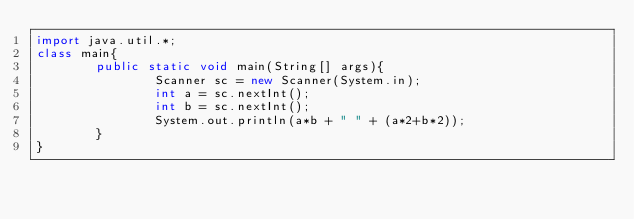Convert code to text. <code><loc_0><loc_0><loc_500><loc_500><_Java_>import java.util.*;
class main{
        public static void main(String[] args){
                Scanner sc = new Scanner(System.in);
                int a = sc.nextInt();
                int b = sc.nextInt();
                System.out.println(a*b + " " + (a*2+b*2));
        }
}</code> 